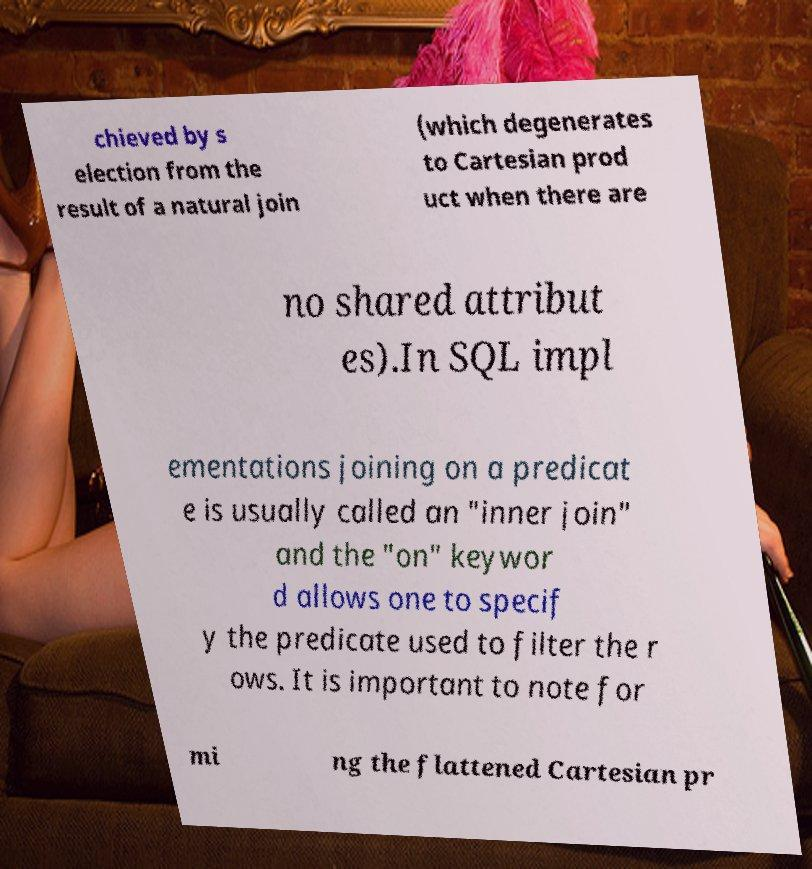What messages or text are displayed in this image? I need them in a readable, typed format. chieved by s election from the result of a natural join (which degenerates to Cartesian prod uct when there are no shared attribut es).In SQL impl ementations joining on a predicat e is usually called an "inner join" and the "on" keywor d allows one to specif y the predicate used to filter the r ows. It is important to note for mi ng the flattened Cartesian pr 